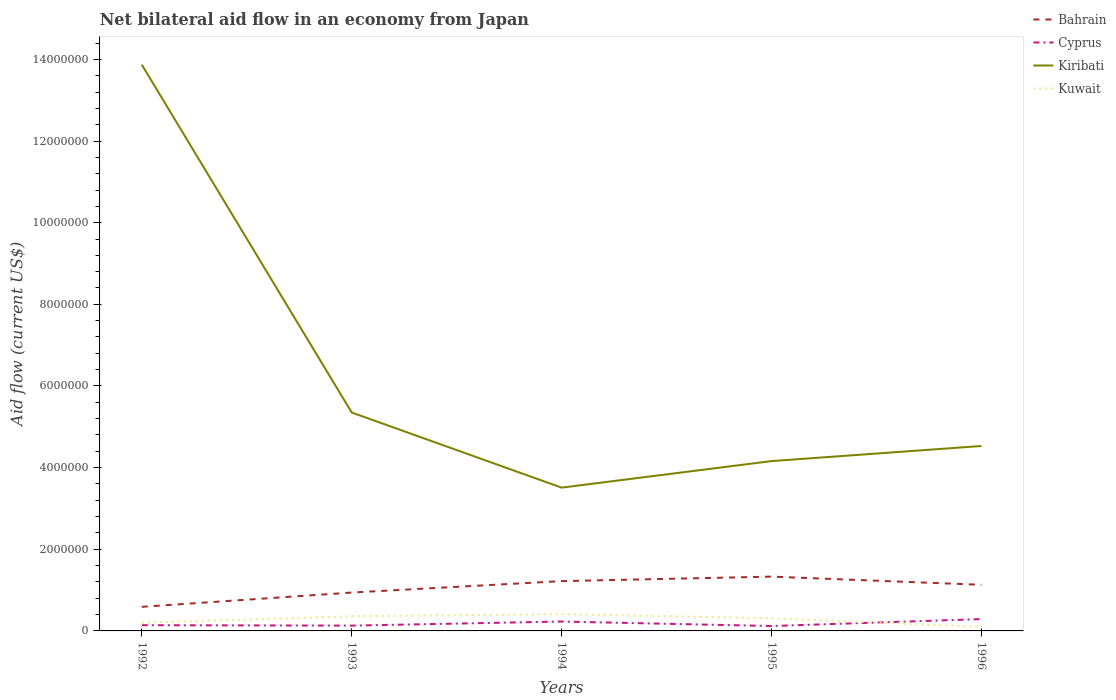How many different coloured lines are there?
Provide a short and direct response. 4. Does the line corresponding to Cyprus intersect with the line corresponding to Kiribati?
Make the answer very short. No. In which year was the net bilateral aid flow in Cyprus maximum?
Offer a very short reply. 1995. What is the total net bilateral aid flow in Bahrain in the graph?
Ensure brevity in your answer.  -1.90e+05. What is the difference between the highest and the second highest net bilateral aid flow in Bahrain?
Offer a very short reply. 7.40e+05. What is the difference between the highest and the lowest net bilateral aid flow in Bahrain?
Make the answer very short. 3. Is the net bilateral aid flow in Kuwait strictly greater than the net bilateral aid flow in Kiribati over the years?
Offer a terse response. Yes. How many years are there in the graph?
Provide a short and direct response. 5. Are the values on the major ticks of Y-axis written in scientific E-notation?
Make the answer very short. No. Where does the legend appear in the graph?
Provide a succinct answer. Top right. How are the legend labels stacked?
Your response must be concise. Vertical. What is the title of the graph?
Offer a very short reply. Net bilateral aid flow in an economy from Japan. What is the label or title of the X-axis?
Your answer should be very brief. Years. What is the Aid flow (current US$) in Bahrain in 1992?
Offer a very short reply. 5.90e+05. What is the Aid flow (current US$) of Cyprus in 1992?
Your answer should be very brief. 1.40e+05. What is the Aid flow (current US$) of Kiribati in 1992?
Keep it short and to the point. 1.39e+07. What is the Aid flow (current US$) in Bahrain in 1993?
Your response must be concise. 9.40e+05. What is the Aid flow (current US$) of Cyprus in 1993?
Provide a succinct answer. 1.30e+05. What is the Aid flow (current US$) of Kiribati in 1993?
Your answer should be very brief. 5.35e+06. What is the Aid flow (current US$) in Kuwait in 1993?
Ensure brevity in your answer.  3.60e+05. What is the Aid flow (current US$) of Bahrain in 1994?
Give a very brief answer. 1.22e+06. What is the Aid flow (current US$) of Cyprus in 1994?
Ensure brevity in your answer.  2.30e+05. What is the Aid flow (current US$) of Kiribati in 1994?
Make the answer very short. 3.51e+06. What is the Aid flow (current US$) in Bahrain in 1995?
Offer a very short reply. 1.33e+06. What is the Aid flow (current US$) in Kiribati in 1995?
Offer a very short reply. 4.16e+06. What is the Aid flow (current US$) of Bahrain in 1996?
Your answer should be very brief. 1.13e+06. What is the Aid flow (current US$) in Kiribati in 1996?
Provide a succinct answer. 4.53e+06. Across all years, what is the maximum Aid flow (current US$) of Bahrain?
Make the answer very short. 1.33e+06. Across all years, what is the maximum Aid flow (current US$) of Kiribati?
Keep it short and to the point. 1.39e+07. Across all years, what is the maximum Aid flow (current US$) of Kuwait?
Keep it short and to the point. 4.10e+05. Across all years, what is the minimum Aid flow (current US$) in Bahrain?
Provide a short and direct response. 5.90e+05. Across all years, what is the minimum Aid flow (current US$) in Cyprus?
Ensure brevity in your answer.  1.20e+05. Across all years, what is the minimum Aid flow (current US$) of Kiribati?
Offer a very short reply. 3.51e+06. What is the total Aid flow (current US$) in Bahrain in the graph?
Provide a short and direct response. 5.21e+06. What is the total Aid flow (current US$) in Cyprus in the graph?
Offer a very short reply. 9.10e+05. What is the total Aid flow (current US$) of Kiribati in the graph?
Offer a terse response. 3.14e+07. What is the total Aid flow (current US$) in Kuwait in the graph?
Your answer should be compact. 1.38e+06. What is the difference between the Aid flow (current US$) of Bahrain in 1992 and that in 1993?
Give a very brief answer. -3.50e+05. What is the difference between the Aid flow (current US$) in Cyprus in 1992 and that in 1993?
Make the answer very short. 10000. What is the difference between the Aid flow (current US$) of Kiribati in 1992 and that in 1993?
Your answer should be compact. 8.52e+06. What is the difference between the Aid flow (current US$) in Kuwait in 1992 and that in 1993?
Your response must be concise. -1.60e+05. What is the difference between the Aid flow (current US$) of Bahrain in 1992 and that in 1994?
Your answer should be compact. -6.30e+05. What is the difference between the Aid flow (current US$) in Kiribati in 1992 and that in 1994?
Keep it short and to the point. 1.04e+07. What is the difference between the Aid flow (current US$) of Bahrain in 1992 and that in 1995?
Your answer should be very brief. -7.40e+05. What is the difference between the Aid flow (current US$) in Cyprus in 1992 and that in 1995?
Give a very brief answer. 2.00e+04. What is the difference between the Aid flow (current US$) of Kiribati in 1992 and that in 1995?
Your answer should be very brief. 9.71e+06. What is the difference between the Aid flow (current US$) in Bahrain in 1992 and that in 1996?
Your response must be concise. -5.40e+05. What is the difference between the Aid flow (current US$) of Cyprus in 1992 and that in 1996?
Provide a short and direct response. -1.50e+05. What is the difference between the Aid flow (current US$) in Kiribati in 1992 and that in 1996?
Your response must be concise. 9.34e+06. What is the difference between the Aid flow (current US$) of Kuwait in 1992 and that in 1996?
Give a very brief answer. 1.00e+05. What is the difference between the Aid flow (current US$) in Bahrain in 1993 and that in 1994?
Your answer should be very brief. -2.80e+05. What is the difference between the Aid flow (current US$) of Kiribati in 1993 and that in 1994?
Your response must be concise. 1.84e+06. What is the difference between the Aid flow (current US$) in Kuwait in 1993 and that in 1994?
Offer a terse response. -5.00e+04. What is the difference between the Aid flow (current US$) of Bahrain in 1993 and that in 1995?
Give a very brief answer. -3.90e+05. What is the difference between the Aid flow (current US$) in Kiribati in 1993 and that in 1995?
Give a very brief answer. 1.19e+06. What is the difference between the Aid flow (current US$) of Kuwait in 1993 and that in 1995?
Provide a short and direct response. 5.00e+04. What is the difference between the Aid flow (current US$) in Cyprus in 1993 and that in 1996?
Offer a terse response. -1.60e+05. What is the difference between the Aid flow (current US$) in Kiribati in 1993 and that in 1996?
Provide a succinct answer. 8.20e+05. What is the difference between the Aid flow (current US$) in Bahrain in 1994 and that in 1995?
Provide a short and direct response. -1.10e+05. What is the difference between the Aid flow (current US$) in Kiribati in 1994 and that in 1995?
Give a very brief answer. -6.50e+05. What is the difference between the Aid flow (current US$) in Cyprus in 1994 and that in 1996?
Offer a terse response. -6.00e+04. What is the difference between the Aid flow (current US$) in Kiribati in 1994 and that in 1996?
Your answer should be compact. -1.02e+06. What is the difference between the Aid flow (current US$) in Kuwait in 1994 and that in 1996?
Your answer should be compact. 3.10e+05. What is the difference between the Aid flow (current US$) of Bahrain in 1995 and that in 1996?
Keep it short and to the point. 2.00e+05. What is the difference between the Aid flow (current US$) in Cyprus in 1995 and that in 1996?
Provide a succinct answer. -1.70e+05. What is the difference between the Aid flow (current US$) of Kiribati in 1995 and that in 1996?
Your response must be concise. -3.70e+05. What is the difference between the Aid flow (current US$) of Kuwait in 1995 and that in 1996?
Provide a succinct answer. 2.10e+05. What is the difference between the Aid flow (current US$) of Bahrain in 1992 and the Aid flow (current US$) of Cyprus in 1993?
Your answer should be compact. 4.60e+05. What is the difference between the Aid flow (current US$) in Bahrain in 1992 and the Aid flow (current US$) in Kiribati in 1993?
Offer a very short reply. -4.76e+06. What is the difference between the Aid flow (current US$) in Bahrain in 1992 and the Aid flow (current US$) in Kuwait in 1993?
Keep it short and to the point. 2.30e+05. What is the difference between the Aid flow (current US$) in Cyprus in 1992 and the Aid flow (current US$) in Kiribati in 1993?
Your answer should be compact. -5.21e+06. What is the difference between the Aid flow (current US$) in Cyprus in 1992 and the Aid flow (current US$) in Kuwait in 1993?
Offer a terse response. -2.20e+05. What is the difference between the Aid flow (current US$) in Kiribati in 1992 and the Aid flow (current US$) in Kuwait in 1993?
Give a very brief answer. 1.35e+07. What is the difference between the Aid flow (current US$) of Bahrain in 1992 and the Aid flow (current US$) of Cyprus in 1994?
Keep it short and to the point. 3.60e+05. What is the difference between the Aid flow (current US$) in Bahrain in 1992 and the Aid flow (current US$) in Kiribati in 1994?
Provide a short and direct response. -2.92e+06. What is the difference between the Aid flow (current US$) in Cyprus in 1992 and the Aid flow (current US$) in Kiribati in 1994?
Offer a terse response. -3.37e+06. What is the difference between the Aid flow (current US$) in Cyprus in 1992 and the Aid flow (current US$) in Kuwait in 1994?
Offer a terse response. -2.70e+05. What is the difference between the Aid flow (current US$) of Kiribati in 1992 and the Aid flow (current US$) of Kuwait in 1994?
Offer a terse response. 1.35e+07. What is the difference between the Aid flow (current US$) of Bahrain in 1992 and the Aid flow (current US$) of Cyprus in 1995?
Your response must be concise. 4.70e+05. What is the difference between the Aid flow (current US$) in Bahrain in 1992 and the Aid flow (current US$) in Kiribati in 1995?
Your answer should be compact. -3.57e+06. What is the difference between the Aid flow (current US$) in Bahrain in 1992 and the Aid flow (current US$) in Kuwait in 1995?
Your answer should be compact. 2.80e+05. What is the difference between the Aid flow (current US$) of Cyprus in 1992 and the Aid flow (current US$) of Kiribati in 1995?
Provide a succinct answer. -4.02e+06. What is the difference between the Aid flow (current US$) in Cyprus in 1992 and the Aid flow (current US$) in Kuwait in 1995?
Offer a very short reply. -1.70e+05. What is the difference between the Aid flow (current US$) of Kiribati in 1992 and the Aid flow (current US$) of Kuwait in 1995?
Ensure brevity in your answer.  1.36e+07. What is the difference between the Aid flow (current US$) in Bahrain in 1992 and the Aid flow (current US$) in Cyprus in 1996?
Your answer should be very brief. 3.00e+05. What is the difference between the Aid flow (current US$) in Bahrain in 1992 and the Aid flow (current US$) in Kiribati in 1996?
Offer a terse response. -3.94e+06. What is the difference between the Aid flow (current US$) of Bahrain in 1992 and the Aid flow (current US$) of Kuwait in 1996?
Your answer should be compact. 4.90e+05. What is the difference between the Aid flow (current US$) in Cyprus in 1992 and the Aid flow (current US$) in Kiribati in 1996?
Your answer should be very brief. -4.39e+06. What is the difference between the Aid flow (current US$) in Kiribati in 1992 and the Aid flow (current US$) in Kuwait in 1996?
Make the answer very short. 1.38e+07. What is the difference between the Aid flow (current US$) of Bahrain in 1993 and the Aid flow (current US$) of Cyprus in 1994?
Your answer should be compact. 7.10e+05. What is the difference between the Aid flow (current US$) in Bahrain in 1993 and the Aid flow (current US$) in Kiribati in 1994?
Ensure brevity in your answer.  -2.57e+06. What is the difference between the Aid flow (current US$) in Bahrain in 1993 and the Aid flow (current US$) in Kuwait in 1994?
Make the answer very short. 5.30e+05. What is the difference between the Aid flow (current US$) in Cyprus in 1993 and the Aid flow (current US$) in Kiribati in 1994?
Provide a short and direct response. -3.38e+06. What is the difference between the Aid flow (current US$) in Cyprus in 1993 and the Aid flow (current US$) in Kuwait in 1994?
Your answer should be compact. -2.80e+05. What is the difference between the Aid flow (current US$) in Kiribati in 1993 and the Aid flow (current US$) in Kuwait in 1994?
Offer a terse response. 4.94e+06. What is the difference between the Aid flow (current US$) of Bahrain in 1993 and the Aid flow (current US$) of Cyprus in 1995?
Offer a terse response. 8.20e+05. What is the difference between the Aid flow (current US$) of Bahrain in 1993 and the Aid flow (current US$) of Kiribati in 1995?
Your answer should be very brief. -3.22e+06. What is the difference between the Aid flow (current US$) in Bahrain in 1993 and the Aid flow (current US$) in Kuwait in 1995?
Offer a terse response. 6.30e+05. What is the difference between the Aid flow (current US$) of Cyprus in 1993 and the Aid flow (current US$) of Kiribati in 1995?
Ensure brevity in your answer.  -4.03e+06. What is the difference between the Aid flow (current US$) of Cyprus in 1993 and the Aid flow (current US$) of Kuwait in 1995?
Your response must be concise. -1.80e+05. What is the difference between the Aid flow (current US$) of Kiribati in 1993 and the Aid flow (current US$) of Kuwait in 1995?
Give a very brief answer. 5.04e+06. What is the difference between the Aid flow (current US$) of Bahrain in 1993 and the Aid flow (current US$) of Cyprus in 1996?
Offer a very short reply. 6.50e+05. What is the difference between the Aid flow (current US$) of Bahrain in 1993 and the Aid flow (current US$) of Kiribati in 1996?
Ensure brevity in your answer.  -3.59e+06. What is the difference between the Aid flow (current US$) in Bahrain in 1993 and the Aid flow (current US$) in Kuwait in 1996?
Provide a succinct answer. 8.40e+05. What is the difference between the Aid flow (current US$) in Cyprus in 1993 and the Aid flow (current US$) in Kiribati in 1996?
Make the answer very short. -4.40e+06. What is the difference between the Aid flow (current US$) in Cyprus in 1993 and the Aid flow (current US$) in Kuwait in 1996?
Offer a terse response. 3.00e+04. What is the difference between the Aid flow (current US$) of Kiribati in 1993 and the Aid flow (current US$) of Kuwait in 1996?
Your response must be concise. 5.25e+06. What is the difference between the Aid flow (current US$) in Bahrain in 1994 and the Aid flow (current US$) in Cyprus in 1995?
Give a very brief answer. 1.10e+06. What is the difference between the Aid flow (current US$) of Bahrain in 1994 and the Aid flow (current US$) of Kiribati in 1995?
Your answer should be very brief. -2.94e+06. What is the difference between the Aid flow (current US$) of Bahrain in 1994 and the Aid flow (current US$) of Kuwait in 1995?
Give a very brief answer. 9.10e+05. What is the difference between the Aid flow (current US$) in Cyprus in 1994 and the Aid flow (current US$) in Kiribati in 1995?
Give a very brief answer. -3.93e+06. What is the difference between the Aid flow (current US$) of Cyprus in 1994 and the Aid flow (current US$) of Kuwait in 1995?
Provide a succinct answer. -8.00e+04. What is the difference between the Aid flow (current US$) in Kiribati in 1994 and the Aid flow (current US$) in Kuwait in 1995?
Ensure brevity in your answer.  3.20e+06. What is the difference between the Aid flow (current US$) in Bahrain in 1994 and the Aid flow (current US$) in Cyprus in 1996?
Offer a very short reply. 9.30e+05. What is the difference between the Aid flow (current US$) of Bahrain in 1994 and the Aid flow (current US$) of Kiribati in 1996?
Your answer should be very brief. -3.31e+06. What is the difference between the Aid flow (current US$) of Bahrain in 1994 and the Aid flow (current US$) of Kuwait in 1996?
Make the answer very short. 1.12e+06. What is the difference between the Aid flow (current US$) of Cyprus in 1994 and the Aid flow (current US$) of Kiribati in 1996?
Provide a succinct answer. -4.30e+06. What is the difference between the Aid flow (current US$) of Cyprus in 1994 and the Aid flow (current US$) of Kuwait in 1996?
Offer a very short reply. 1.30e+05. What is the difference between the Aid flow (current US$) in Kiribati in 1994 and the Aid flow (current US$) in Kuwait in 1996?
Provide a short and direct response. 3.41e+06. What is the difference between the Aid flow (current US$) of Bahrain in 1995 and the Aid flow (current US$) of Cyprus in 1996?
Your response must be concise. 1.04e+06. What is the difference between the Aid flow (current US$) of Bahrain in 1995 and the Aid flow (current US$) of Kiribati in 1996?
Give a very brief answer. -3.20e+06. What is the difference between the Aid flow (current US$) of Bahrain in 1995 and the Aid flow (current US$) of Kuwait in 1996?
Your response must be concise. 1.23e+06. What is the difference between the Aid flow (current US$) of Cyprus in 1995 and the Aid flow (current US$) of Kiribati in 1996?
Offer a very short reply. -4.41e+06. What is the difference between the Aid flow (current US$) of Kiribati in 1995 and the Aid flow (current US$) of Kuwait in 1996?
Give a very brief answer. 4.06e+06. What is the average Aid flow (current US$) of Bahrain per year?
Your answer should be very brief. 1.04e+06. What is the average Aid flow (current US$) of Cyprus per year?
Your response must be concise. 1.82e+05. What is the average Aid flow (current US$) in Kiribati per year?
Provide a short and direct response. 6.28e+06. What is the average Aid flow (current US$) of Kuwait per year?
Provide a succinct answer. 2.76e+05. In the year 1992, what is the difference between the Aid flow (current US$) of Bahrain and Aid flow (current US$) of Kiribati?
Provide a short and direct response. -1.33e+07. In the year 1992, what is the difference between the Aid flow (current US$) of Bahrain and Aid flow (current US$) of Kuwait?
Your answer should be very brief. 3.90e+05. In the year 1992, what is the difference between the Aid flow (current US$) of Cyprus and Aid flow (current US$) of Kiribati?
Offer a very short reply. -1.37e+07. In the year 1992, what is the difference between the Aid flow (current US$) in Cyprus and Aid flow (current US$) in Kuwait?
Your answer should be compact. -6.00e+04. In the year 1992, what is the difference between the Aid flow (current US$) in Kiribati and Aid flow (current US$) in Kuwait?
Offer a terse response. 1.37e+07. In the year 1993, what is the difference between the Aid flow (current US$) in Bahrain and Aid flow (current US$) in Cyprus?
Give a very brief answer. 8.10e+05. In the year 1993, what is the difference between the Aid flow (current US$) of Bahrain and Aid flow (current US$) of Kiribati?
Your answer should be very brief. -4.41e+06. In the year 1993, what is the difference between the Aid flow (current US$) in Bahrain and Aid flow (current US$) in Kuwait?
Keep it short and to the point. 5.80e+05. In the year 1993, what is the difference between the Aid flow (current US$) of Cyprus and Aid flow (current US$) of Kiribati?
Offer a very short reply. -5.22e+06. In the year 1993, what is the difference between the Aid flow (current US$) of Kiribati and Aid flow (current US$) of Kuwait?
Your answer should be compact. 4.99e+06. In the year 1994, what is the difference between the Aid flow (current US$) of Bahrain and Aid flow (current US$) of Cyprus?
Your response must be concise. 9.90e+05. In the year 1994, what is the difference between the Aid flow (current US$) of Bahrain and Aid flow (current US$) of Kiribati?
Your response must be concise. -2.29e+06. In the year 1994, what is the difference between the Aid flow (current US$) in Bahrain and Aid flow (current US$) in Kuwait?
Your answer should be compact. 8.10e+05. In the year 1994, what is the difference between the Aid flow (current US$) in Cyprus and Aid flow (current US$) in Kiribati?
Your answer should be very brief. -3.28e+06. In the year 1994, what is the difference between the Aid flow (current US$) in Cyprus and Aid flow (current US$) in Kuwait?
Your response must be concise. -1.80e+05. In the year 1994, what is the difference between the Aid flow (current US$) in Kiribati and Aid flow (current US$) in Kuwait?
Keep it short and to the point. 3.10e+06. In the year 1995, what is the difference between the Aid flow (current US$) in Bahrain and Aid flow (current US$) in Cyprus?
Make the answer very short. 1.21e+06. In the year 1995, what is the difference between the Aid flow (current US$) in Bahrain and Aid flow (current US$) in Kiribati?
Offer a very short reply. -2.83e+06. In the year 1995, what is the difference between the Aid flow (current US$) in Bahrain and Aid flow (current US$) in Kuwait?
Give a very brief answer. 1.02e+06. In the year 1995, what is the difference between the Aid flow (current US$) in Cyprus and Aid flow (current US$) in Kiribati?
Offer a very short reply. -4.04e+06. In the year 1995, what is the difference between the Aid flow (current US$) of Cyprus and Aid flow (current US$) of Kuwait?
Make the answer very short. -1.90e+05. In the year 1995, what is the difference between the Aid flow (current US$) in Kiribati and Aid flow (current US$) in Kuwait?
Your answer should be very brief. 3.85e+06. In the year 1996, what is the difference between the Aid flow (current US$) of Bahrain and Aid flow (current US$) of Cyprus?
Offer a very short reply. 8.40e+05. In the year 1996, what is the difference between the Aid flow (current US$) of Bahrain and Aid flow (current US$) of Kiribati?
Your answer should be very brief. -3.40e+06. In the year 1996, what is the difference between the Aid flow (current US$) in Bahrain and Aid flow (current US$) in Kuwait?
Offer a terse response. 1.03e+06. In the year 1996, what is the difference between the Aid flow (current US$) of Cyprus and Aid flow (current US$) of Kiribati?
Offer a very short reply. -4.24e+06. In the year 1996, what is the difference between the Aid flow (current US$) in Kiribati and Aid flow (current US$) in Kuwait?
Give a very brief answer. 4.43e+06. What is the ratio of the Aid flow (current US$) in Bahrain in 1992 to that in 1993?
Ensure brevity in your answer.  0.63. What is the ratio of the Aid flow (current US$) of Kiribati in 1992 to that in 1993?
Offer a terse response. 2.59. What is the ratio of the Aid flow (current US$) of Kuwait in 1992 to that in 1993?
Your response must be concise. 0.56. What is the ratio of the Aid flow (current US$) of Bahrain in 1992 to that in 1994?
Your answer should be compact. 0.48. What is the ratio of the Aid flow (current US$) in Cyprus in 1992 to that in 1994?
Offer a very short reply. 0.61. What is the ratio of the Aid flow (current US$) of Kiribati in 1992 to that in 1994?
Offer a terse response. 3.95. What is the ratio of the Aid flow (current US$) of Kuwait in 1992 to that in 1994?
Provide a short and direct response. 0.49. What is the ratio of the Aid flow (current US$) of Bahrain in 1992 to that in 1995?
Provide a succinct answer. 0.44. What is the ratio of the Aid flow (current US$) in Cyprus in 1992 to that in 1995?
Your answer should be compact. 1.17. What is the ratio of the Aid flow (current US$) of Kiribati in 1992 to that in 1995?
Provide a short and direct response. 3.33. What is the ratio of the Aid flow (current US$) in Kuwait in 1992 to that in 1995?
Provide a short and direct response. 0.65. What is the ratio of the Aid flow (current US$) of Bahrain in 1992 to that in 1996?
Ensure brevity in your answer.  0.52. What is the ratio of the Aid flow (current US$) of Cyprus in 1992 to that in 1996?
Your answer should be very brief. 0.48. What is the ratio of the Aid flow (current US$) in Kiribati in 1992 to that in 1996?
Your answer should be compact. 3.06. What is the ratio of the Aid flow (current US$) in Kuwait in 1992 to that in 1996?
Provide a short and direct response. 2. What is the ratio of the Aid flow (current US$) in Bahrain in 1993 to that in 1994?
Offer a very short reply. 0.77. What is the ratio of the Aid flow (current US$) in Cyprus in 1993 to that in 1994?
Your answer should be compact. 0.57. What is the ratio of the Aid flow (current US$) of Kiribati in 1993 to that in 1994?
Your response must be concise. 1.52. What is the ratio of the Aid flow (current US$) of Kuwait in 1993 to that in 1994?
Ensure brevity in your answer.  0.88. What is the ratio of the Aid flow (current US$) of Bahrain in 1993 to that in 1995?
Your answer should be very brief. 0.71. What is the ratio of the Aid flow (current US$) of Kiribati in 1993 to that in 1995?
Provide a succinct answer. 1.29. What is the ratio of the Aid flow (current US$) of Kuwait in 1993 to that in 1995?
Keep it short and to the point. 1.16. What is the ratio of the Aid flow (current US$) in Bahrain in 1993 to that in 1996?
Keep it short and to the point. 0.83. What is the ratio of the Aid flow (current US$) in Cyprus in 1993 to that in 1996?
Provide a short and direct response. 0.45. What is the ratio of the Aid flow (current US$) of Kiribati in 1993 to that in 1996?
Provide a short and direct response. 1.18. What is the ratio of the Aid flow (current US$) of Kuwait in 1993 to that in 1996?
Keep it short and to the point. 3.6. What is the ratio of the Aid flow (current US$) of Bahrain in 1994 to that in 1995?
Your answer should be compact. 0.92. What is the ratio of the Aid flow (current US$) in Cyprus in 1994 to that in 1995?
Your answer should be compact. 1.92. What is the ratio of the Aid flow (current US$) of Kiribati in 1994 to that in 1995?
Keep it short and to the point. 0.84. What is the ratio of the Aid flow (current US$) in Kuwait in 1994 to that in 1995?
Provide a short and direct response. 1.32. What is the ratio of the Aid flow (current US$) in Bahrain in 1994 to that in 1996?
Provide a short and direct response. 1.08. What is the ratio of the Aid flow (current US$) in Cyprus in 1994 to that in 1996?
Keep it short and to the point. 0.79. What is the ratio of the Aid flow (current US$) in Kiribati in 1994 to that in 1996?
Your answer should be compact. 0.77. What is the ratio of the Aid flow (current US$) of Bahrain in 1995 to that in 1996?
Your answer should be very brief. 1.18. What is the ratio of the Aid flow (current US$) in Cyprus in 1995 to that in 1996?
Ensure brevity in your answer.  0.41. What is the ratio of the Aid flow (current US$) of Kiribati in 1995 to that in 1996?
Offer a very short reply. 0.92. What is the ratio of the Aid flow (current US$) in Kuwait in 1995 to that in 1996?
Your answer should be very brief. 3.1. What is the difference between the highest and the second highest Aid flow (current US$) of Cyprus?
Your answer should be very brief. 6.00e+04. What is the difference between the highest and the second highest Aid flow (current US$) of Kiribati?
Keep it short and to the point. 8.52e+06. What is the difference between the highest and the lowest Aid flow (current US$) of Bahrain?
Make the answer very short. 7.40e+05. What is the difference between the highest and the lowest Aid flow (current US$) of Kiribati?
Provide a short and direct response. 1.04e+07. 